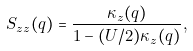Convert formula to latex. <formula><loc_0><loc_0><loc_500><loc_500>S _ { z z } ( q ) = \frac { \kappa _ { z } ( q ) } { 1 - ( U / 2 ) \kappa _ { z } ( q ) } ,</formula> 